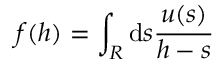Convert formula to latex. <formula><loc_0><loc_0><loc_500><loc_500>f ( h ) = \int _ { R } d s \frac { u ( s ) } { h - s }</formula> 